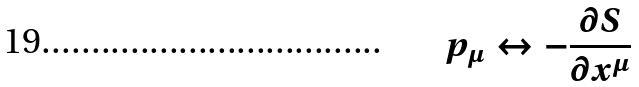<formula> <loc_0><loc_0><loc_500><loc_500>p _ { \mu } \leftrightarrow - \frac { \partial S } { \partial x ^ { \mu } }</formula> 